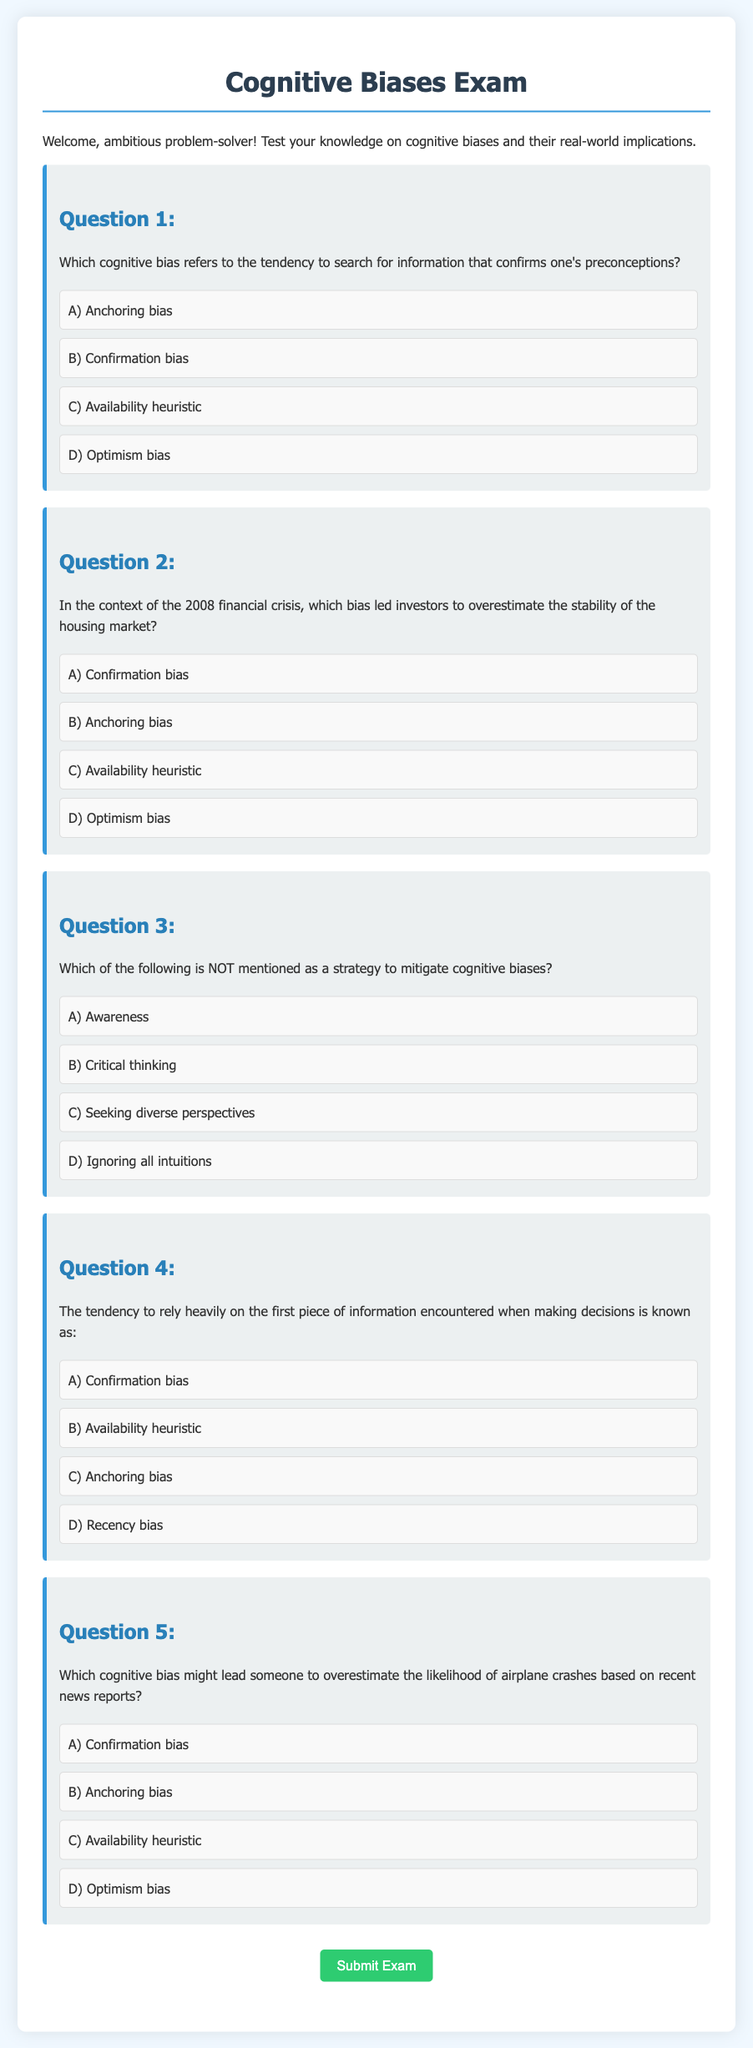What is the title of the document? The title of the document, as indicated in the HTML code, is part of the <title> tag within the <head> section.
Answer: Cognitive Biases Exam Who is the intended audience of the exam? The intended audience is mentioned in the introductory paragraph, welcoming a specific group of individuals.
Answer: ambitious problem-solver What is the color scheme of the document's body background? The background color of the body is defined in the CSS style section with a specific color code.
Answer: #f0f8ff What is the first cognitive bias mentioned in the options for Question 1? The options for Question 1 are presented in a specific order, and the first option is indicated clearly in the structure of the question.
Answer: A) Anchoring bias Which bias led investors to overestimate the stability of the housing market according to Question 2? Question 2 directly asks about a specific cognitive bias relevant to the financial context provided.
Answer: D) Optimism bias What cognitive bias is described as the tendency to rely on the first piece of information encountered? The description is given in Question 4, specifying a bias that influences decision-making behavior.
Answer: C) Anchoring bias Which cognitive bias might lead someone to overestimate the likelihood of airplane crashes? This question specifically asks about the cognitive bias related to recent news reports and is found in Question 5.
Answer: C) Availability heuristic What is the purpose of the styles defined in the document? The styles in the document contribute to the visual presentation of the content, enhancing user experience.
Answer: visual presentation What kind of questions does this document primarily consist of? The type of questions present in the document is indicated in the context of the exam description.
Answer: short-answer questions 